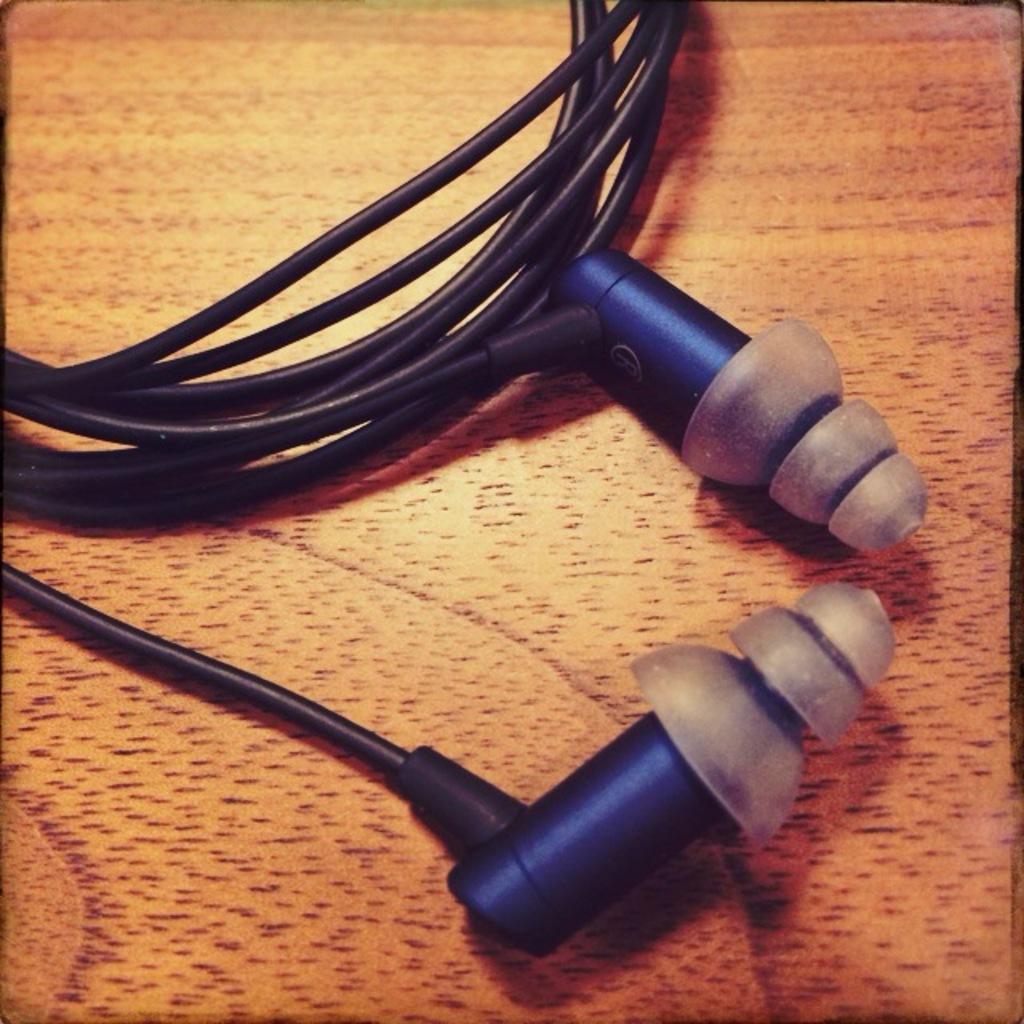Could you give a brief overview of what you see in this image? In this image there is the headphone which is on the surface which is black in colour and blue in colour. 